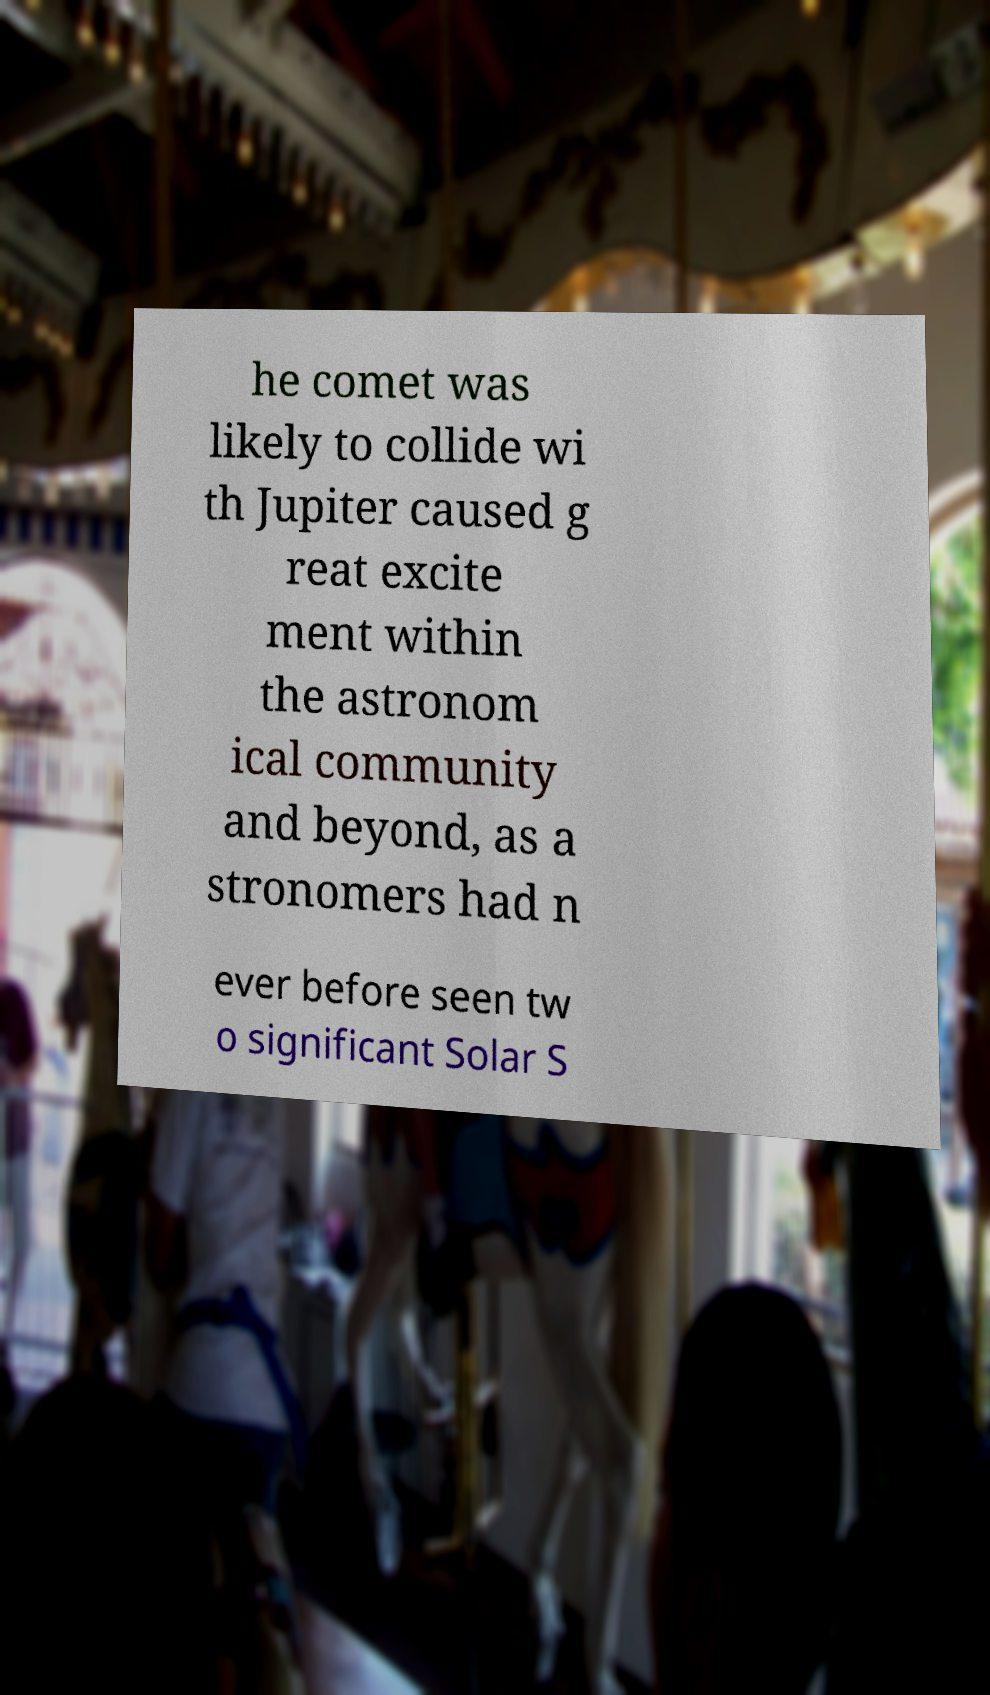There's text embedded in this image that I need extracted. Can you transcribe it verbatim? he comet was likely to collide wi th Jupiter caused g reat excite ment within the astronom ical community and beyond, as a stronomers had n ever before seen tw o significant Solar S 